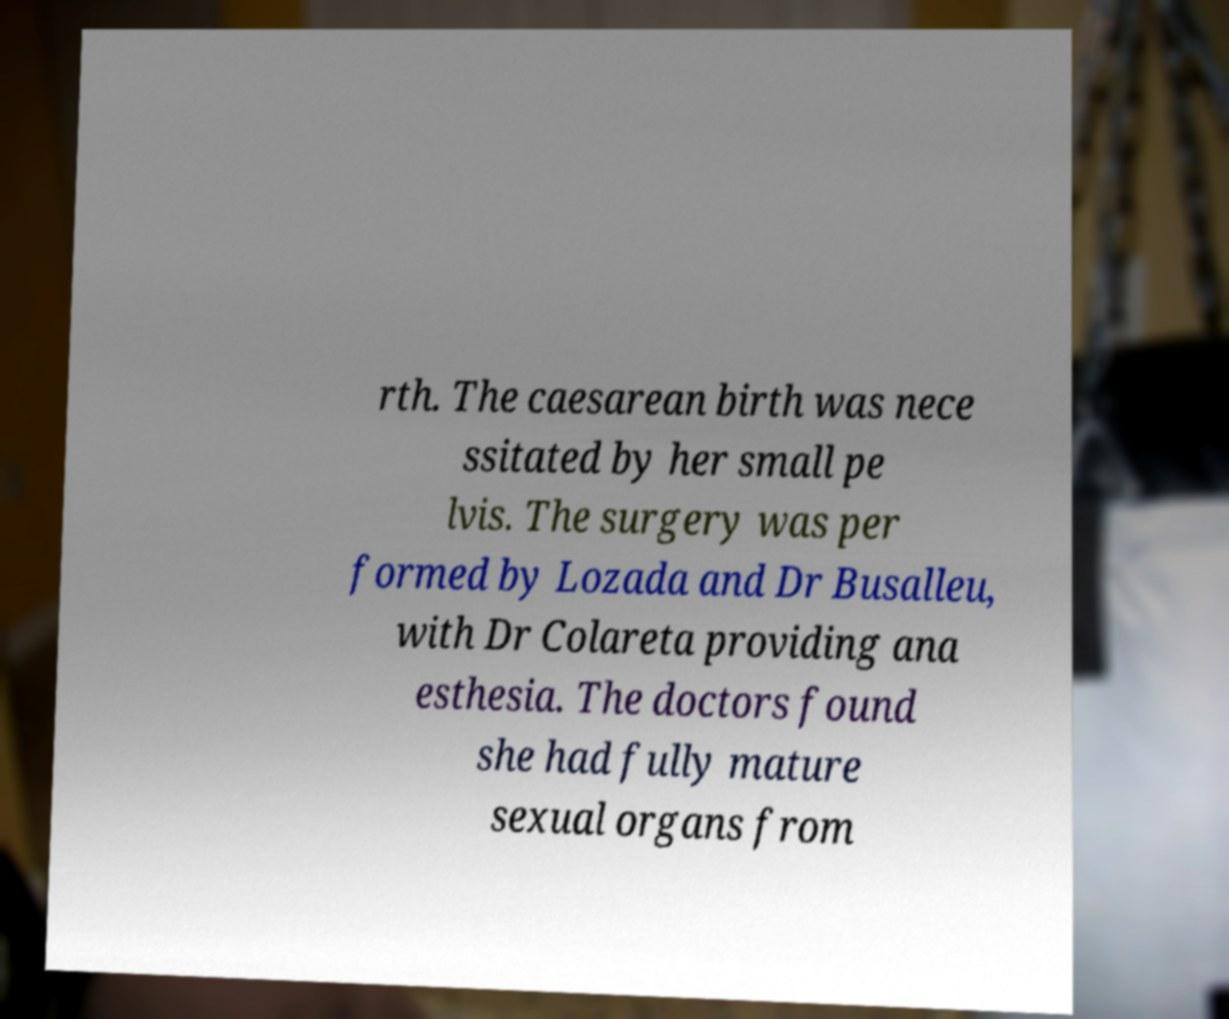What messages or text are displayed in this image? I need them in a readable, typed format. rth. The caesarean birth was nece ssitated by her small pe lvis. The surgery was per formed by Lozada and Dr Busalleu, with Dr Colareta providing ana esthesia. The doctors found she had fully mature sexual organs from 